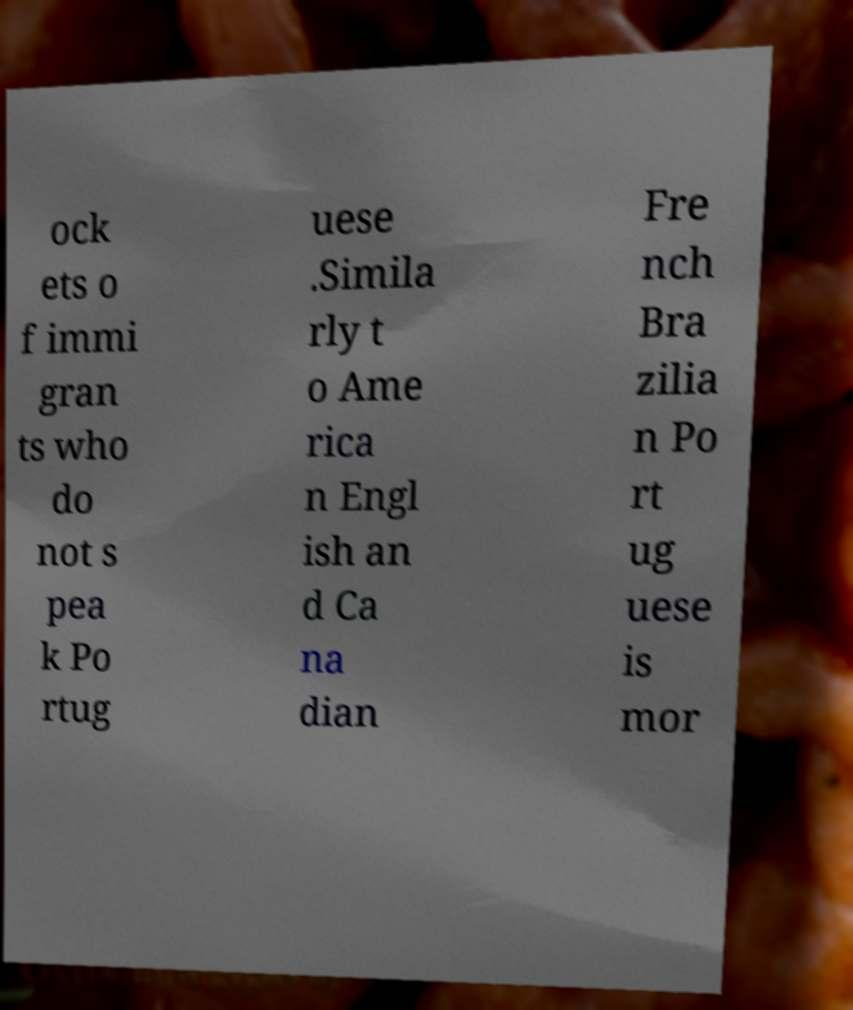Please read and relay the text visible in this image. What does it say? ock ets o f immi gran ts who do not s pea k Po rtug uese .Simila rly t o Ame rica n Engl ish an d Ca na dian Fre nch Bra zilia n Po rt ug uese is mor 